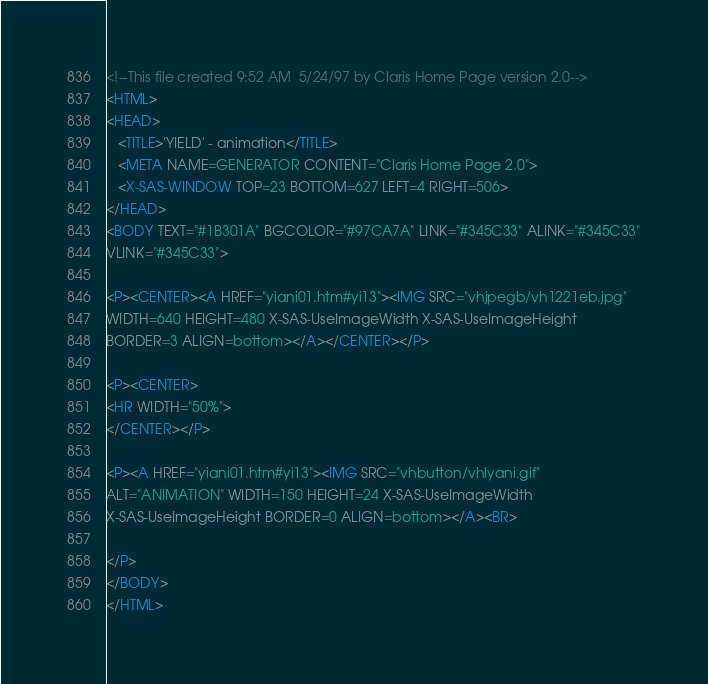Convert code to text. <code><loc_0><loc_0><loc_500><loc_500><_HTML_><!--This file created 9:52 AM  5/24/97 by Claris Home Page version 2.0-->
<HTML>
<HEAD>
   <TITLE>'YIELD' - animation</TITLE>
   <META NAME=GENERATOR CONTENT="Claris Home Page 2.0">
   <X-SAS-WINDOW TOP=23 BOTTOM=627 LEFT=4 RIGHT=506>
</HEAD>
<BODY TEXT="#1B301A" BGCOLOR="#97CA7A" LINK="#345C33" ALINK="#345C33"
VLINK="#345C33">

<P><CENTER><A HREF="yiani01.htm#yi13"><IMG SRC="vhjpegb/vh1221eb.jpg"
WIDTH=640 HEIGHT=480 X-SAS-UseImageWidth X-SAS-UseImageHeight
BORDER=3 ALIGN=bottom></A></CENTER></P>

<P><CENTER>
<HR WIDTH="50%">
</CENTER></P>

<P><A HREF="yiani01.htm#yi13"><IMG SRC="vhbutton/vhlyani.gif"
ALT="ANIMATION" WIDTH=150 HEIGHT=24 X-SAS-UseImageWidth
X-SAS-UseImageHeight BORDER=0 ALIGN=bottom></A><BR>

</P>
</BODY>
</HTML>
</code> 